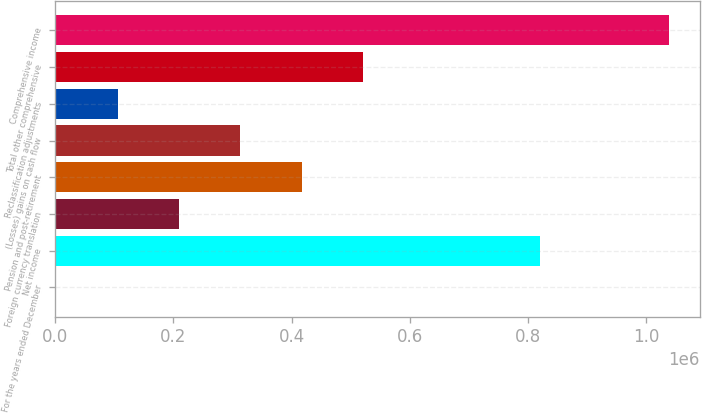<chart> <loc_0><loc_0><loc_500><loc_500><bar_chart><fcel>For the years ended December<fcel>Net income<fcel>Foreign currency translation<fcel>Pension and post-retirement<fcel>(Losses) gains on cash flow<fcel>Reclassification adjustments<fcel>Total other comprehensive<fcel>Comprehensive income<nl><fcel>2013<fcel>820470<fcel>209406<fcel>416799<fcel>313103<fcel>105710<fcel>520496<fcel>1.03898e+06<nl></chart> 